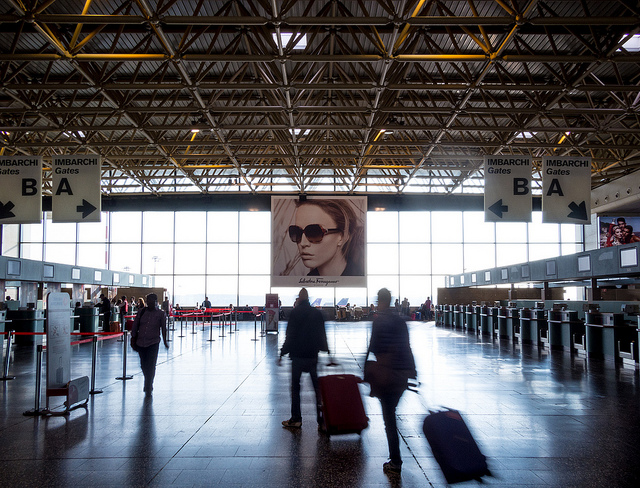Read all the text in this image. Gates A IMBRACHI IMBRACHI Gatos ates IMBARCHI 